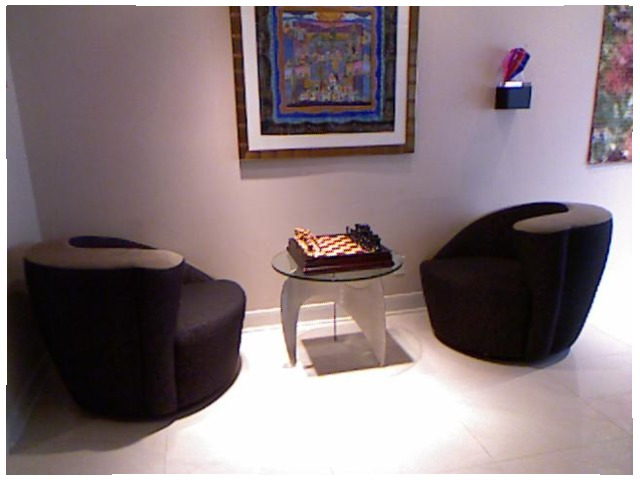<image>
Can you confirm if the thermostat is in front of the painting? No. The thermostat is not in front of the painting. The spatial positioning shows a different relationship between these objects. Is the chess board in front of the table? No. The chess board is not in front of the table. The spatial positioning shows a different relationship between these objects. Is there a game on the table? Yes. Looking at the image, I can see the game is positioned on top of the table, with the table providing support. Is there a table on the wall? No. The table is not positioned on the wall. They may be near each other, but the table is not supported by or resting on top of the wall. Is there a picture on the table? No. The picture is not positioned on the table. They may be near each other, but the picture is not supported by or resting on top of the table. Is there a chess board above the floor? Yes. The chess board is positioned above the floor in the vertical space, higher up in the scene. 